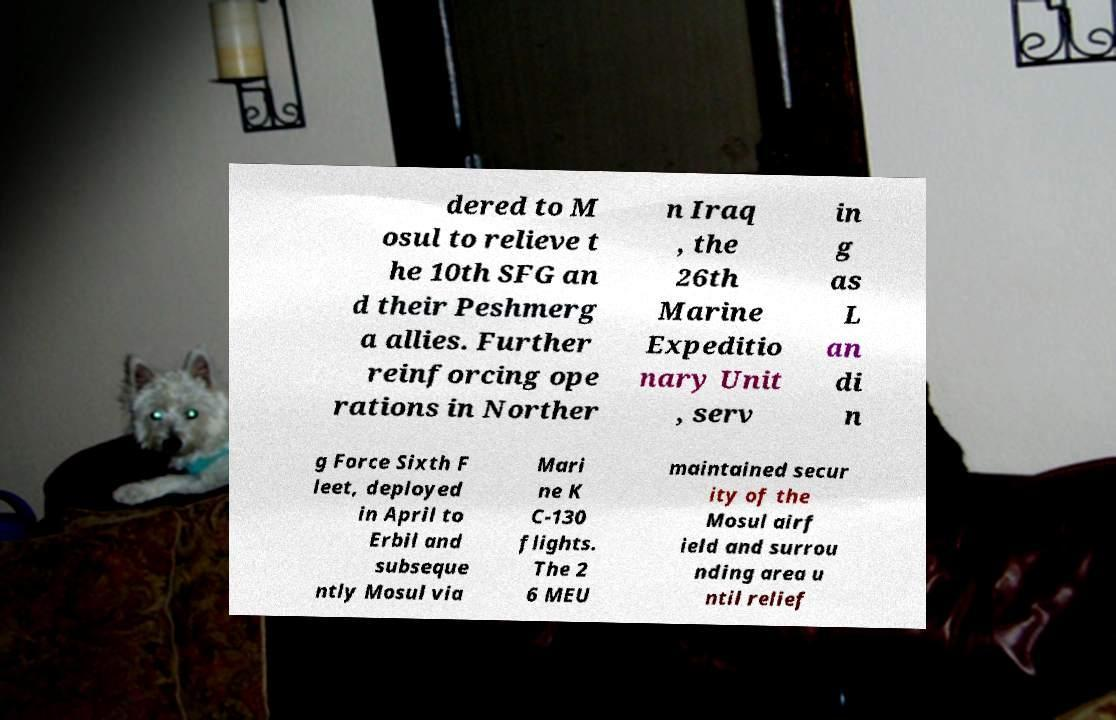Please identify and transcribe the text found in this image. dered to M osul to relieve t he 10th SFG an d their Peshmerg a allies. Further reinforcing ope rations in Norther n Iraq , the 26th Marine Expeditio nary Unit , serv in g as L an di n g Force Sixth F leet, deployed in April to Erbil and subseque ntly Mosul via Mari ne K C-130 flights. The 2 6 MEU maintained secur ity of the Mosul airf ield and surrou nding area u ntil relief 